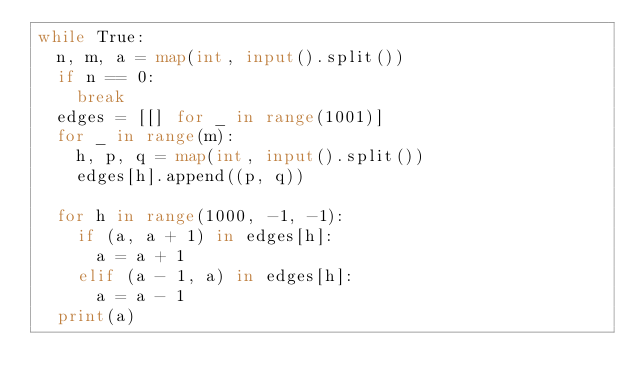Convert code to text. <code><loc_0><loc_0><loc_500><loc_500><_Python_>while True:
  n, m, a = map(int, input().split())
  if n == 0:
    break
  edges = [[] for _ in range(1001)]
  for _ in range(m):
    h, p, q = map(int, input().split())
    edges[h].append((p, q))
  
  for h in range(1000, -1, -1):
    if (a, a + 1) in edges[h]:
      a = a + 1
    elif (a - 1, a) in edges[h]:
      a = a - 1
  print(a)

</code> 